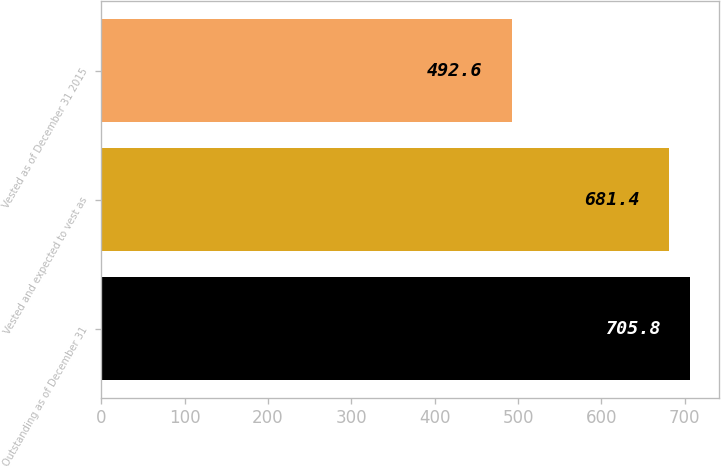<chart> <loc_0><loc_0><loc_500><loc_500><bar_chart><fcel>Outstanding as of December 31<fcel>Vested and expected to vest as<fcel>Vested as of December 31 2015<nl><fcel>705.8<fcel>681.4<fcel>492.6<nl></chart> 